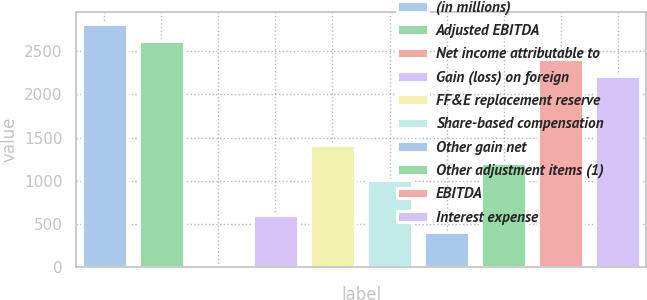<chart> <loc_0><loc_0><loc_500><loc_500><bar_chart><fcel>(in millions)<fcel>Adjusted EBITDA<fcel>Net income attributable to<fcel>Gain (loss) on foreign<fcel>FF&E replacement reserve<fcel>Share-based compensation<fcel>Other gain net<fcel>Other adjustment items (1)<fcel>EBITDA<fcel>Interest expense<nl><fcel>2814<fcel>2613.5<fcel>7<fcel>608.5<fcel>1410.5<fcel>1009.5<fcel>408<fcel>1210<fcel>2413<fcel>2212.5<nl></chart> 